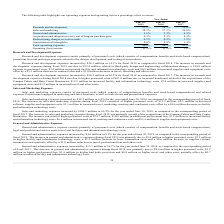From Extreme Networks's financial document, Which years does the table provide information for the company's operating expenses and operating loss as a percentage of net revenues? The document contains multiple relevant values: 2019, 2018, 2017. From the document: "2017 2019 2018..." Also, What was Research and Development as a percentage of net revenues in 2018? According to the financial document, 18.7 (percentage). The relevant text states: "Research and development 21.1% 18.7% 15.4%..." Also, What was Sales and Marketing as a percentage of net revenues in 2019? According to the financial document, 28.7 (percentage). The relevant text states: "Sales and marketing 28.7% 27.2% 26.8%..." Also, How many years did Sales and Marketing as a percentage of net revenues exceed 20%? Counting the relevant items in the document: 2019, 2018, 2017, I find 3 instances. The key data points involved are: 2017, 2018, 2019. Additionally, Which years did General and administrative as a percentage of net revenues exceed 6%? According to the financial document, 2017. The relevant text states: "2017..." Also, can you calculate: What was the change in the Total operating expenses as a percentage of net revenues between 2018 and 2019? Based on the calculation: 56.8-58.3, the result is -1.5 (percentage). This is based on the information: "Total operating expenses 56.8% 58.3% 53.5% Total operating expenses 56.8% 58.3% 53.5%..." The key data points involved are: 56.8, 58.3. 